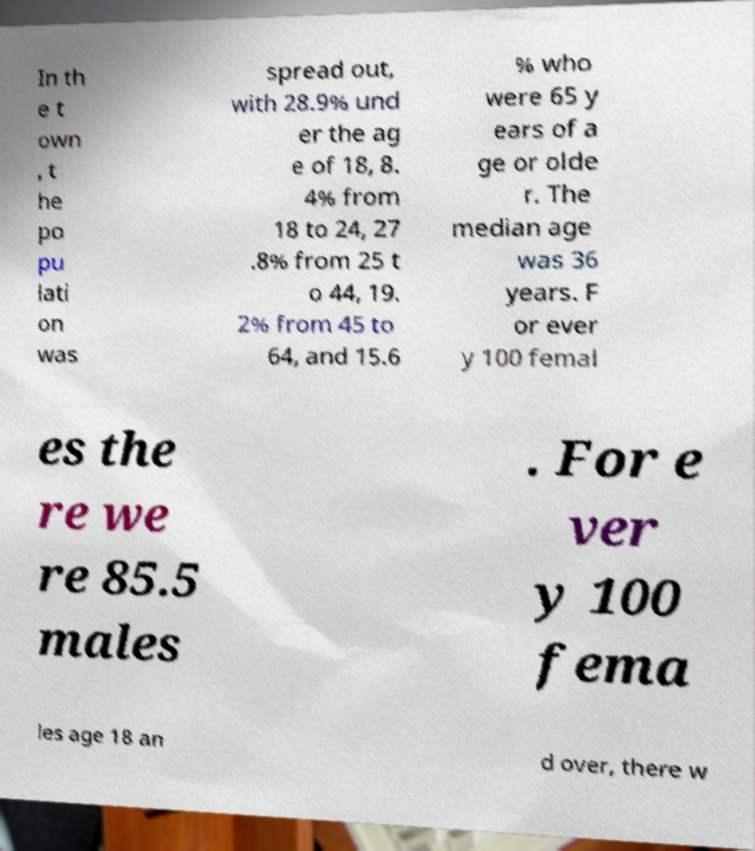There's text embedded in this image that I need extracted. Can you transcribe it verbatim? In th e t own , t he po pu lati on was spread out, with 28.9% und er the ag e of 18, 8. 4% from 18 to 24, 27 .8% from 25 t o 44, 19. 2% from 45 to 64, and 15.6 % who were 65 y ears of a ge or olde r. The median age was 36 years. F or ever y 100 femal es the re we re 85.5 males . For e ver y 100 fema les age 18 an d over, there w 